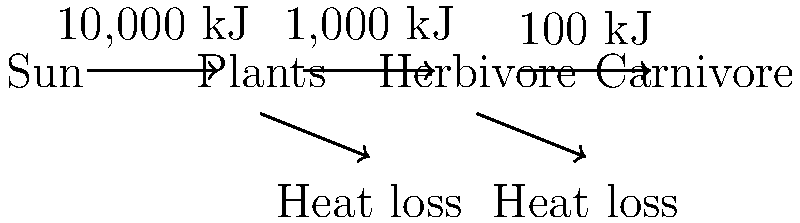In this food chain diagram, what percentage of energy is transferred from the herbivore to the carnivore, and how does this illustrate the concept of energy efficiency in ecosystems? To solve this question, let's follow these steps:

1. Identify the energy values:
   - Plants receive 10,000 kJ from the sun
   - Herbivores receive 1,000 kJ from plants
   - Carnivores receive 100 kJ from herbivores

2. Calculate the energy transfer percentage from herbivore to carnivore:
   $\text{Percentage} = \frac{\text{Energy received by carnivore}}{\text{Energy in herbivore}} \times 100\%$
   $= \frac{100 \text{ kJ}}{1,000 \text{ kJ}} \times 100\% = 10\%$

3. Understand the concept of energy efficiency:
   - Only a small portion of energy is transferred between trophic levels
   - This is due to energy loss through various processes:
     a) Heat loss (as shown in the diagram)
     b) Movement and other life processes
     c) Undigested food and waste

4. Ecological implications:
   - The 10% energy transfer is typical in most ecosystems
   - This low efficiency explains why food chains are usually limited to 4-5 trophic levels
   - It also demonstrates why there are fewer organisms at higher trophic levels

5. Relate to holistic nutrition:
   - Understanding energy flow in ecosystems can inform dietary choices
   - Consuming foods from lower trophic levels (e.g., plants) is generally more energy-efficient
   - This concept aligns with principles of sustainable and plant-based diets
Answer: 10% energy transfer; illustrates decreasing energy availability at higher trophic levels due to heat loss and inefficiencies. 